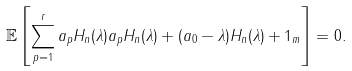Convert formula to latex. <formula><loc_0><loc_0><loc_500><loc_500>\mathbb { E } \left [ \sum _ { p = 1 } ^ { r } a _ { p } H _ { n } ( \lambda ) a _ { p } H _ { n } ( \lambda ) + ( a _ { 0 } - \lambda ) H _ { n } ( \lambda ) + 1 _ { m } \right ] = 0 .</formula> 